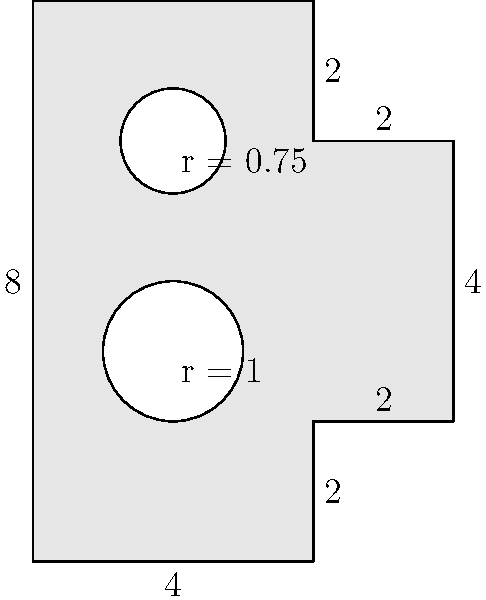As a music critic with a keen eye for instrument shapes, you're analyzing the area of a stylized guitar-shaped polygon. The guitar is composed of a rectangle and two circular sound holes. If the large rectangle measures 8 units in height and 4 units in width, with two additional 2x2 unit squares attached to its right side, and the sound holes have radii of 1 unit and 0.75 units respectively, what is the total area of the guitar-shaped polygon? Let's break this down step-by-step:

1) First, let's calculate the area of the main rectangle:
   $A_{rectangle} = 8 \times 4 = 32$ square units

2) Now, add the area of the two additional squares:
   $A_{squares} = 2 \times (2 \times 2) = 8$ square units

3) The total area of the polygon without the holes is:
   $A_{total} = 32 + 8 = 40$ square units

4) Now, we need to subtract the areas of the circular sound holes:
   
   For the larger hole: $A_{hole1} = \pi r^2 = \pi (1)^2 = \pi$ square units
   
   For the smaller hole: $A_{hole2} = \pi r^2 = \pi (0.75)^2 = 0.5625\pi$ square units

5) The total area to be subtracted is:
   $A_{holes} = \pi + 0.5625\pi = 1.5625\pi$ square units

6) Therefore, the final area of the guitar-shaped polygon is:
   $A_{guitar} = A_{total} - A_{holes} = 40 - 1.5625\pi$ square units
Answer: $40 - 1.5625\pi$ square units 